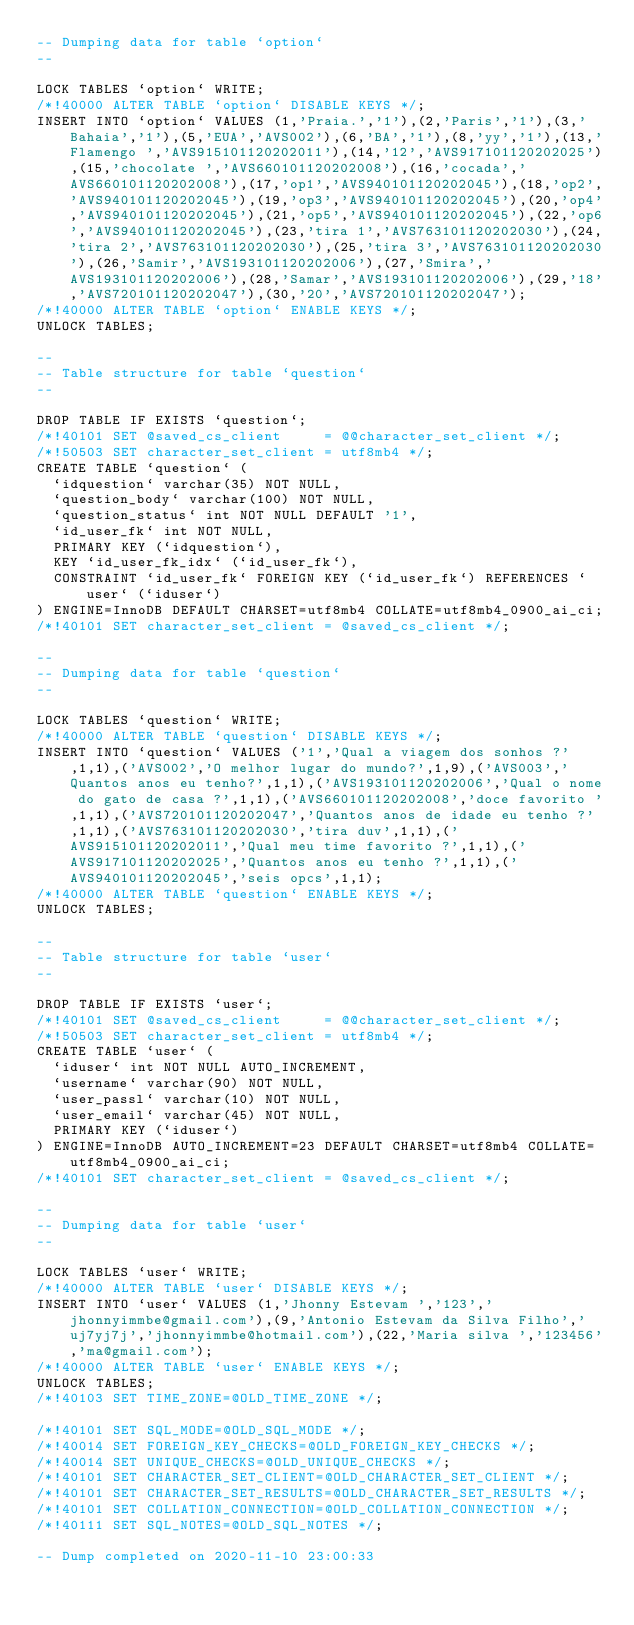Convert code to text. <code><loc_0><loc_0><loc_500><loc_500><_SQL_>-- Dumping data for table `option`
--

LOCK TABLES `option` WRITE;
/*!40000 ALTER TABLE `option` DISABLE KEYS */;
INSERT INTO `option` VALUES (1,'Praia.','1'),(2,'Paris','1'),(3,'Bahaia','1'),(5,'EUA','AVS002'),(6,'BA','1'),(8,'yy','1'),(13,'Flamengo ','AVS915101120202011'),(14,'12','AVS917101120202025'),(15,'chocolate ','AVS660101120202008'),(16,'cocada','AVS660101120202008'),(17,'op1','AVS940101120202045'),(18,'op2','AVS940101120202045'),(19,'op3','AVS940101120202045'),(20,'op4','AVS940101120202045'),(21,'op5','AVS940101120202045'),(22,'op6','AVS940101120202045'),(23,'tira 1','AVS763101120202030'),(24,'tira 2','AVS763101120202030'),(25,'tira 3','AVS763101120202030'),(26,'Samir','AVS193101120202006'),(27,'Smira','AVS193101120202006'),(28,'Samar','AVS193101120202006'),(29,'18','AVS720101120202047'),(30,'20','AVS720101120202047');
/*!40000 ALTER TABLE `option` ENABLE KEYS */;
UNLOCK TABLES;

--
-- Table structure for table `question`
--

DROP TABLE IF EXISTS `question`;
/*!40101 SET @saved_cs_client     = @@character_set_client */;
/*!50503 SET character_set_client = utf8mb4 */;
CREATE TABLE `question` (
  `idquestion` varchar(35) NOT NULL,
  `question_body` varchar(100) NOT NULL,
  `question_status` int NOT NULL DEFAULT '1',
  `id_user_fk` int NOT NULL,
  PRIMARY KEY (`idquestion`),
  KEY `id_user_fk_idx` (`id_user_fk`),
  CONSTRAINT `id_user_fk` FOREIGN KEY (`id_user_fk`) REFERENCES `user` (`iduser`)
) ENGINE=InnoDB DEFAULT CHARSET=utf8mb4 COLLATE=utf8mb4_0900_ai_ci;
/*!40101 SET character_set_client = @saved_cs_client */;

--
-- Dumping data for table `question`
--

LOCK TABLES `question` WRITE;
/*!40000 ALTER TABLE `question` DISABLE KEYS */;
INSERT INTO `question` VALUES ('1','Qual a viagem dos sonhos ?',1,1),('AVS002','O melhor lugar do mundo?',1,9),('AVS003','Quantos anos eu tenho?',1,1),('AVS193101120202006','Qual o nome do gato de casa ?',1,1),('AVS660101120202008','doce favorito ',1,1),('AVS720101120202047','Quantos anos de idade eu tenho ?',1,1),('AVS763101120202030','tira duv',1,1),('AVS915101120202011','Qual meu time favorito ?',1,1),('AVS917101120202025','Quantos anos eu tenho ?',1,1),('AVS940101120202045','seis opcs',1,1);
/*!40000 ALTER TABLE `question` ENABLE KEYS */;
UNLOCK TABLES;

--
-- Table structure for table `user`
--

DROP TABLE IF EXISTS `user`;
/*!40101 SET @saved_cs_client     = @@character_set_client */;
/*!50503 SET character_set_client = utf8mb4 */;
CREATE TABLE `user` (
  `iduser` int NOT NULL AUTO_INCREMENT,
  `username` varchar(90) NOT NULL,
  `user_passl` varchar(10) NOT NULL,
  `user_email` varchar(45) NOT NULL,
  PRIMARY KEY (`iduser`)
) ENGINE=InnoDB AUTO_INCREMENT=23 DEFAULT CHARSET=utf8mb4 COLLATE=utf8mb4_0900_ai_ci;
/*!40101 SET character_set_client = @saved_cs_client */;

--
-- Dumping data for table `user`
--

LOCK TABLES `user` WRITE;
/*!40000 ALTER TABLE `user` DISABLE KEYS */;
INSERT INTO `user` VALUES (1,'Jhonny Estevam ','123','jhonnyimmbe@gmail.com'),(9,'Antonio Estevam da Silva Filho','uj7yj7j','jhonnyimmbe@hotmail.com'),(22,'Maria silva ','123456','ma@gmail.com');
/*!40000 ALTER TABLE `user` ENABLE KEYS */;
UNLOCK TABLES;
/*!40103 SET TIME_ZONE=@OLD_TIME_ZONE */;

/*!40101 SET SQL_MODE=@OLD_SQL_MODE */;
/*!40014 SET FOREIGN_KEY_CHECKS=@OLD_FOREIGN_KEY_CHECKS */;
/*!40014 SET UNIQUE_CHECKS=@OLD_UNIQUE_CHECKS */;
/*!40101 SET CHARACTER_SET_CLIENT=@OLD_CHARACTER_SET_CLIENT */;
/*!40101 SET CHARACTER_SET_RESULTS=@OLD_CHARACTER_SET_RESULTS */;
/*!40101 SET COLLATION_CONNECTION=@OLD_COLLATION_CONNECTION */;
/*!40111 SET SQL_NOTES=@OLD_SQL_NOTES */;

-- Dump completed on 2020-11-10 23:00:33
</code> 